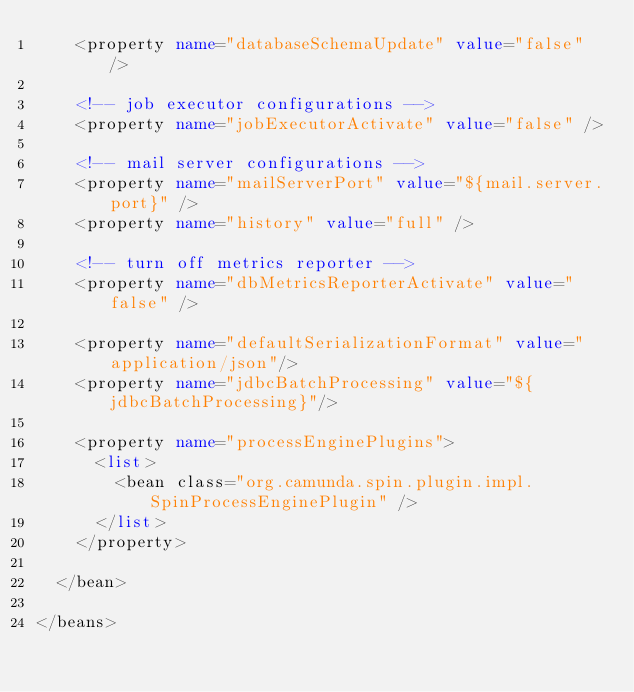Convert code to text. <code><loc_0><loc_0><loc_500><loc_500><_XML_>    <property name="databaseSchemaUpdate" value="false" />
    
    <!-- job executor configurations -->
    <property name="jobExecutorActivate" value="false" />

    <!-- mail server configurations -->
    <property name="mailServerPort" value="${mail.server.port}" />
    <property name="history" value="full" />

    <!-- turn off metrics reporter -->
    <property name="dbMetricsReporterActivate" value="false" />

    <property name="defaultSerializationFormat" value="application/json"/>
    <property name="jdbcBatchProcessing" value="${jdbcBatchProcessing}"/>

    <property name="processEnginePlugins">
      <list>
        <bean class="org.camunda.spin.plugin.impl.SpinProcessEnginePlugin" />
      </list>
    </property>

  </bean>
  
</beans>
</code> 